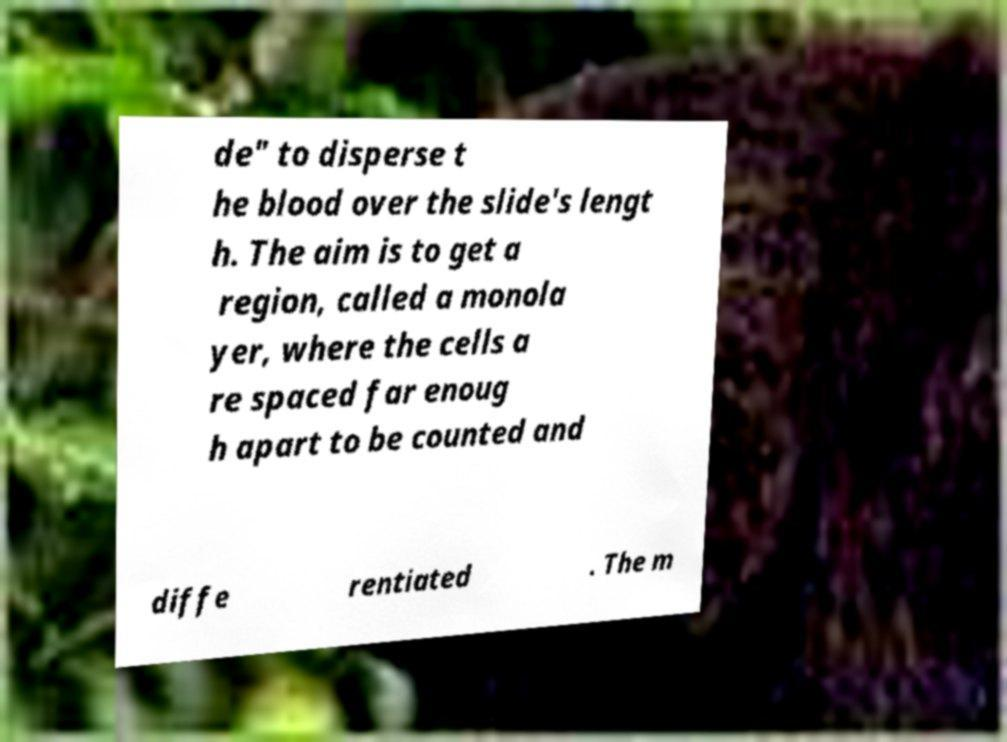Can you accurately transcribe the text from the provided image for me? de" to disperse t he blood over the slide's lengt h. The aim is to get a region, called a monola yer, where the cells a re spaced far enoug h apart to be counted and diffe rentiated . The m 